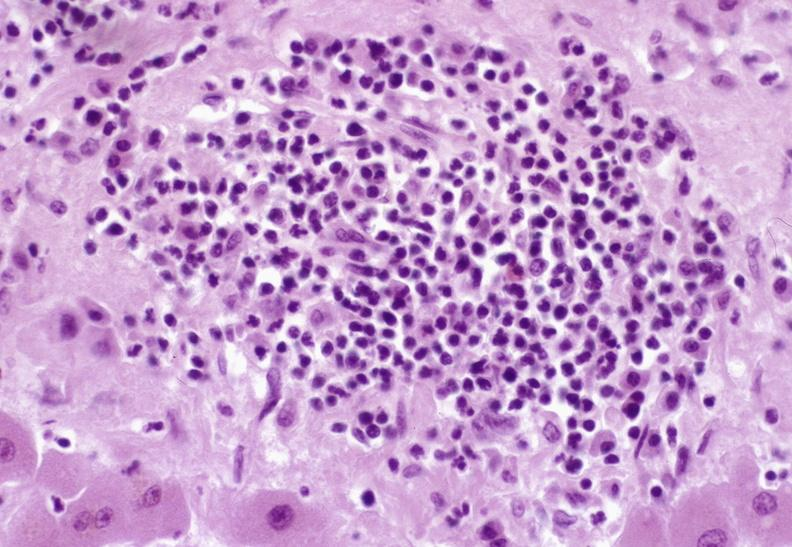does this image show severe acute rejection?
Answer the question using a single word or phrase. Yes 